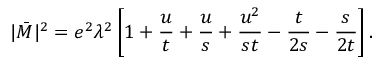<formula> <loc_0><loc_0><loc_500><loc_500>| \bar { M } | ^ { 2 } = e ^ { 2 } \lambda ^ { 2 } \left [ 1 + \frac { u } { t } + \frac { u } { s } + \frac { u ^ { 2 } } { s t } - \frac { t } { 2 s } - \frac { s } { 2 t } \right ] .</formula> 